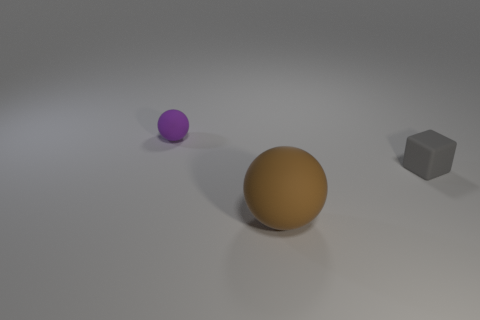There is a thing that is the same size as the gray cube; what color is it?
Offer a very short reply. Purple. Are there any yellow shiny cubes that have the same size as the purple rubber thing?
Provide a short and direct response. No. How many rubber objects are large cyan cylinders or tiny gray cubes?
Provide a short and direct response. 1. How many big brown blocks are there?
Make the answer very short. 0. Are the small object that is left of the small gray matte cube and the small object that is on the right side of the large brown rubber thing made of the same material?
Your response must be concise. Yes. The brown object that is the same material as the cube is what size?
Give a very brief answer. Large. There is a object in front of the tiny gray thing; what shape is it?
Give a very brief answer. Sphere. Are there any big brown matte things?
Provide a succinct answer. Yes. What shape is the small object that is to the left of the small object that is on the right side of the tiny matte thing behind the small gray rubber cube?
Make the answer very short. Sphere. What number of objects are on the left side of the brown rubber sphere?
Offer a terse response. 1. 